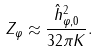Convert formula to latex. <formula><loc_0><loc_0><loc_500><loc_500>Z _ { \varphi } \approx \frac { \hat { h } ^ { 2 } _ { \varphi , 0 } } { 3 2 \pi K } .</formula> 